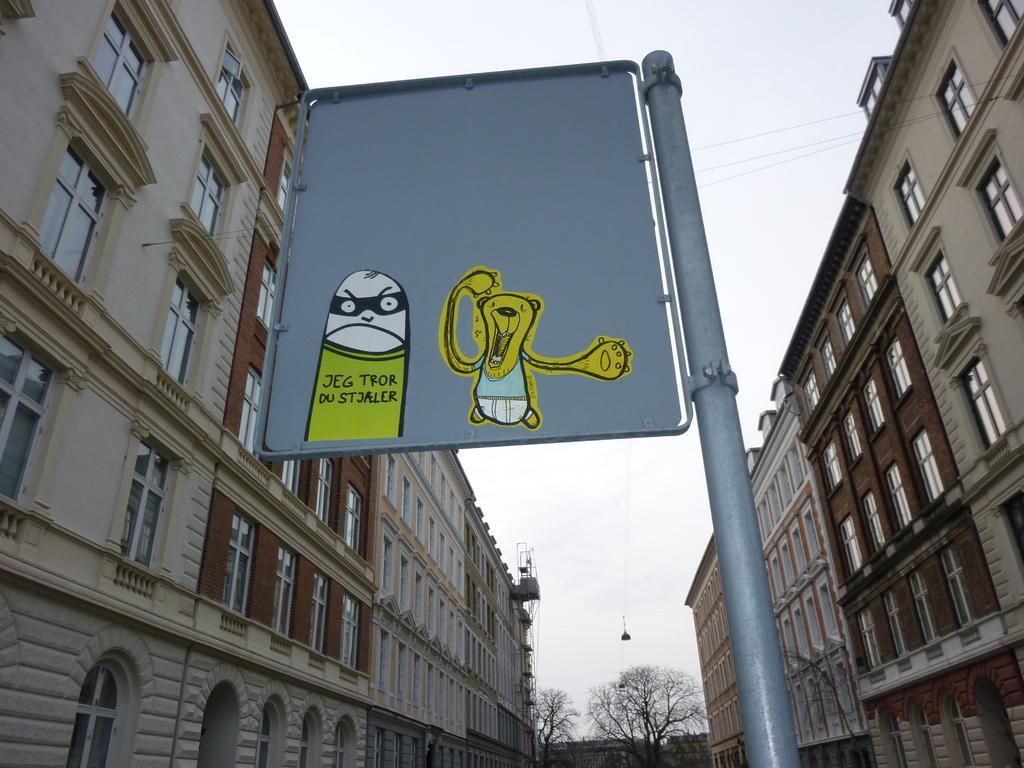Please provide a concise description of this image. This picture is clicked outside. In the center we can see the pictures of some cartoons on the board and the board is attached to the metal rod. On both the sides we can see the buildings and windows of the buildings. In the background we can see the sky, dry stems, method rods and some other objects. 